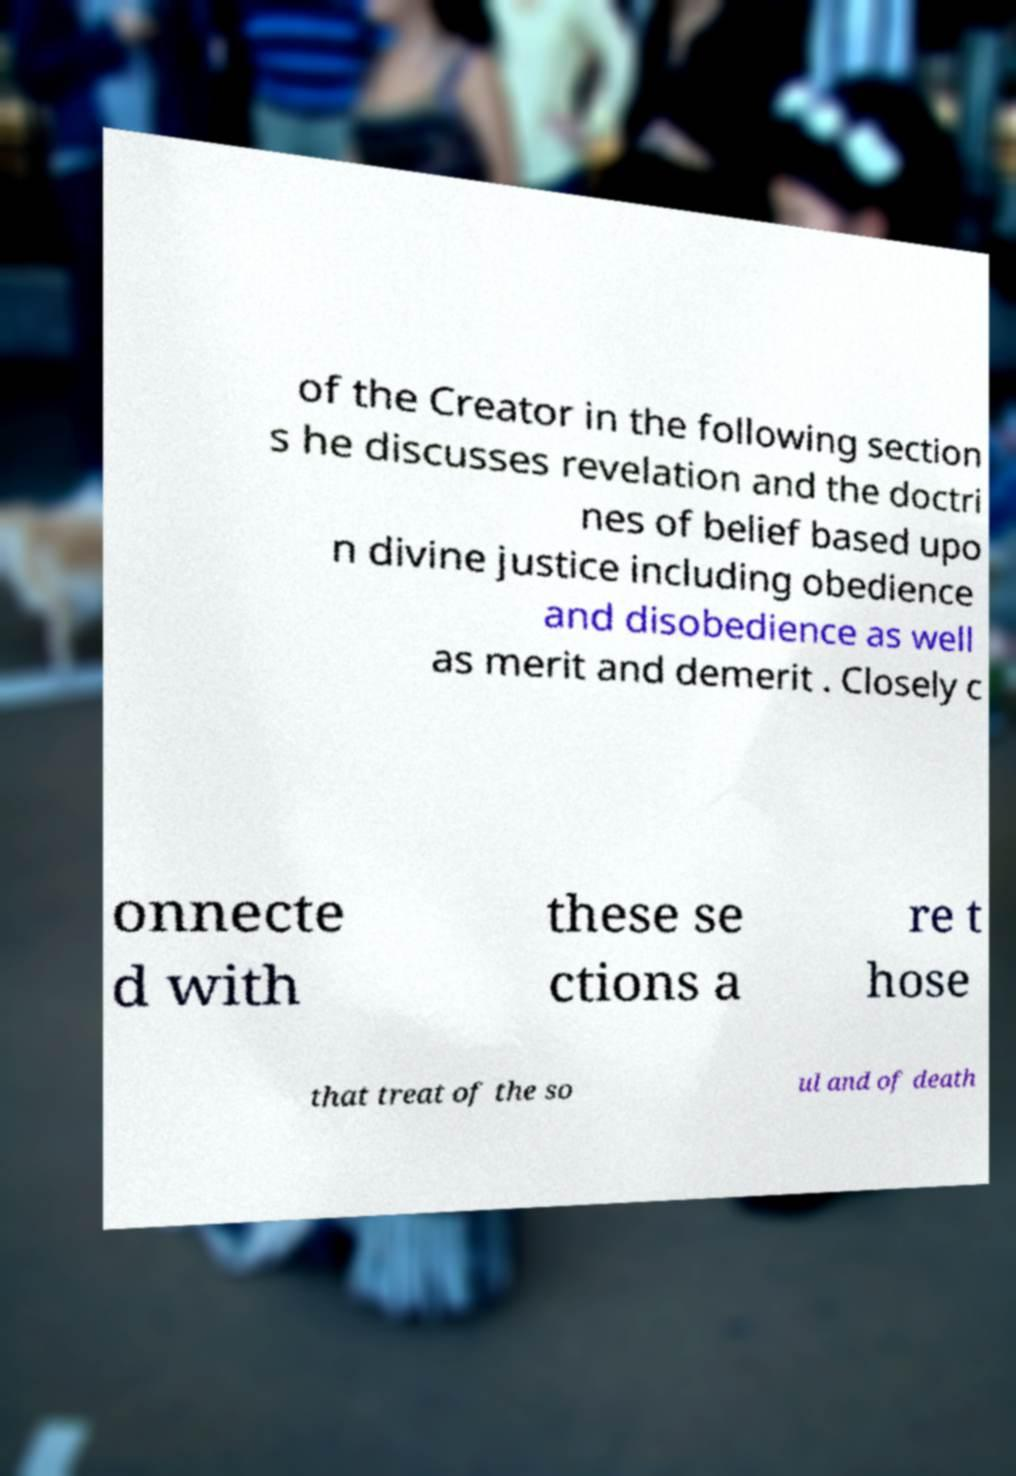I need the written content from this picture converted into text. Can you do that? of the Creator in the following section s he discusses revelation and the doctri nes of belief based upo n divine justice including obedience and disobedience as well as merit and demerit . Closely c onnecte d with these se ctions a re t hose that treat of the so ul and of death 